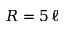<formula> <loc_0><loc_0><loc_500><loc_500>R = 5 \, \ell</formula> 